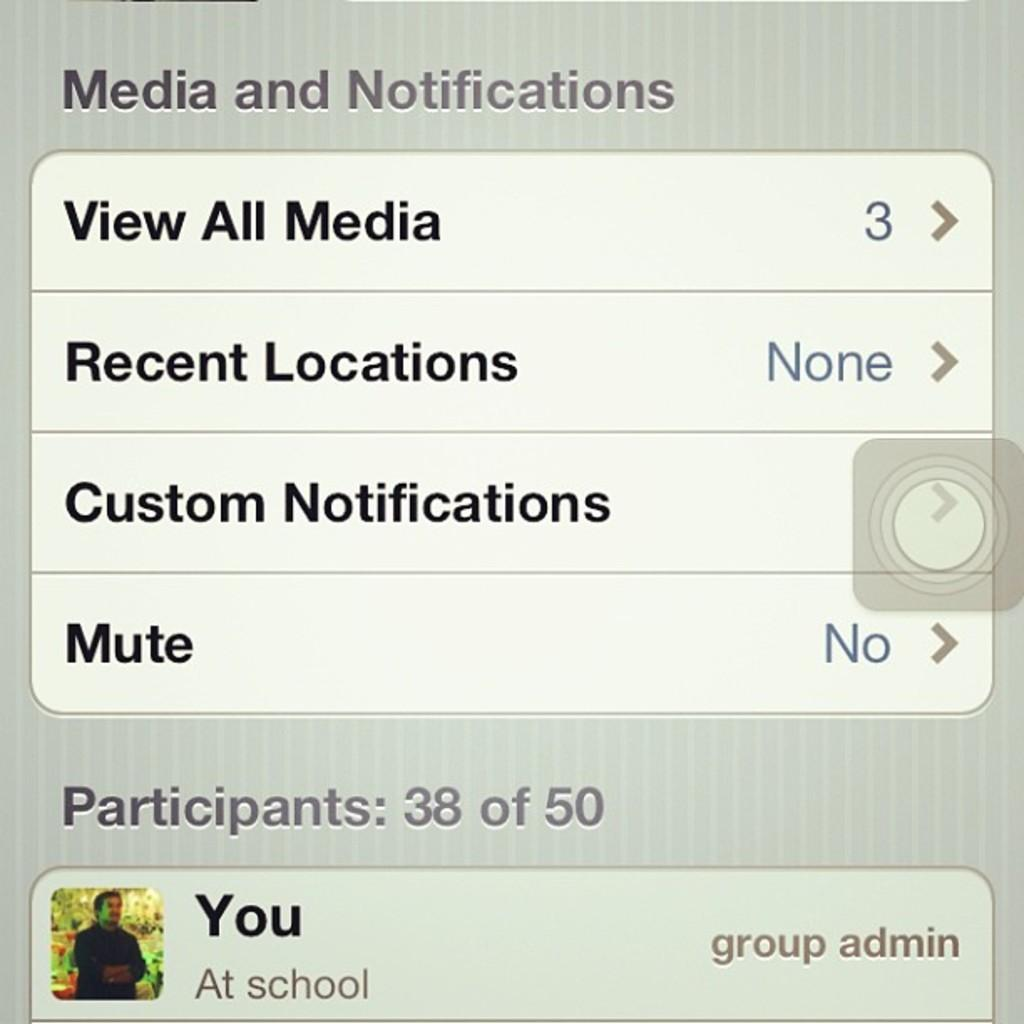What is the main subject of the image? The main subject of the image is a mobile screenshot. Can you describe the content of the mobile screenshot? The mobile screenshot features a person and some text. How many dolls are sitting on the jewel in the image? There are no dolls or jewels present in the image; it features a mobile screenshot with a person and some text. 